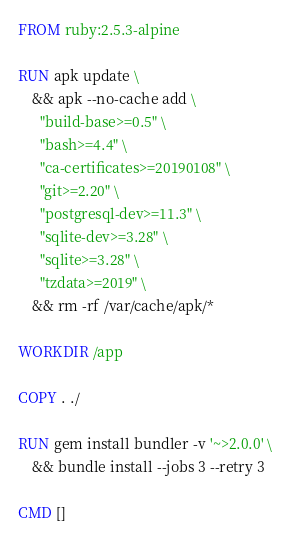<code> <loc_0><loc_0><loc_500><loc_500><_Dockerfile_>FROM ruby:2.5.3-alpine

RUN apk update \
    && apk --no-cache add \
      "build-base>=0.5" \
      "bash>=4.4" \
      "ca-certificates>=20190108" \
      "git>=2.20" \
      "postgresql-dev>=11.3" \
      "sqlite-dev>=3.28" \
      "sqlite>=3.28" \
      "tzdata>=2019" \
    && rm -rf /var/cache/apk/*

WORKDIR /app

COPY . ./

RUN gem install bundler -v '~>2.0.0' \
    && bundle install --jobs 3 --retry 3

CMD []
</code> 